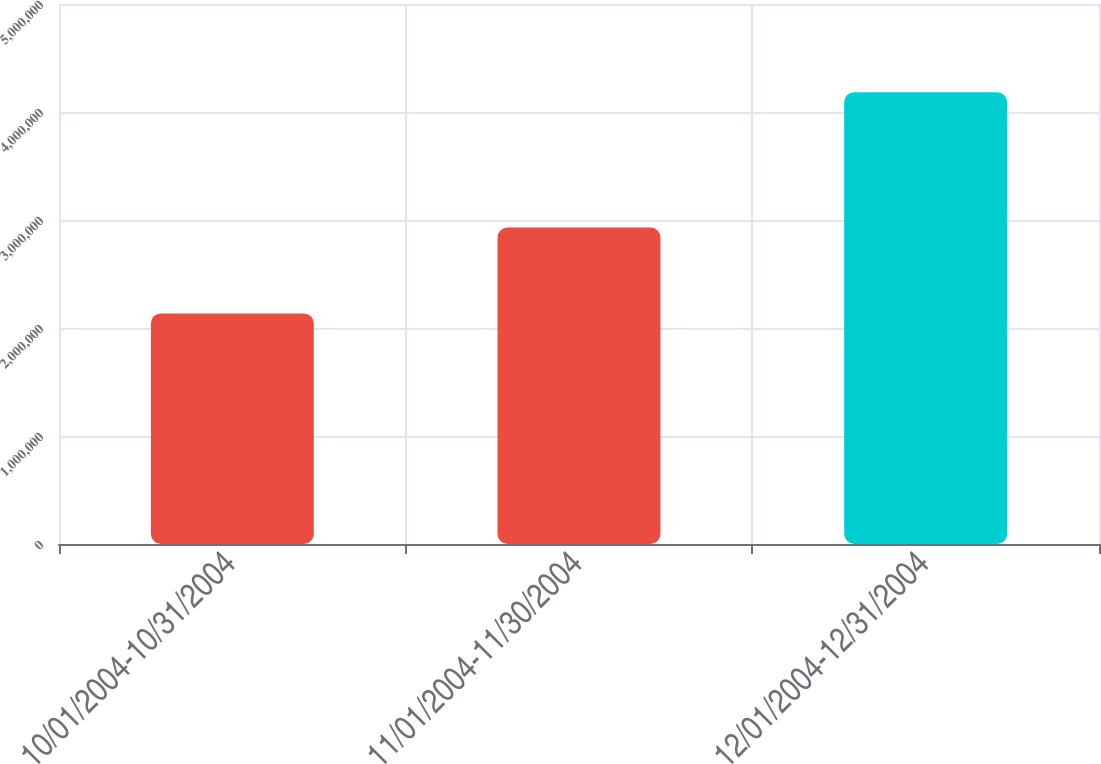Convert chart. <chart><loc_0><loc_0><loc_500><loc_500><bar_chart><fcel>10/01/2004-10/31/2004<fcel>11/01/2004-11/30/2004<fcel>12/01/2004-12/31/2004<nl><fcel>2.135e+06<fcel>2.931e+06<fcel>4.1838e+06<nl></chart> 